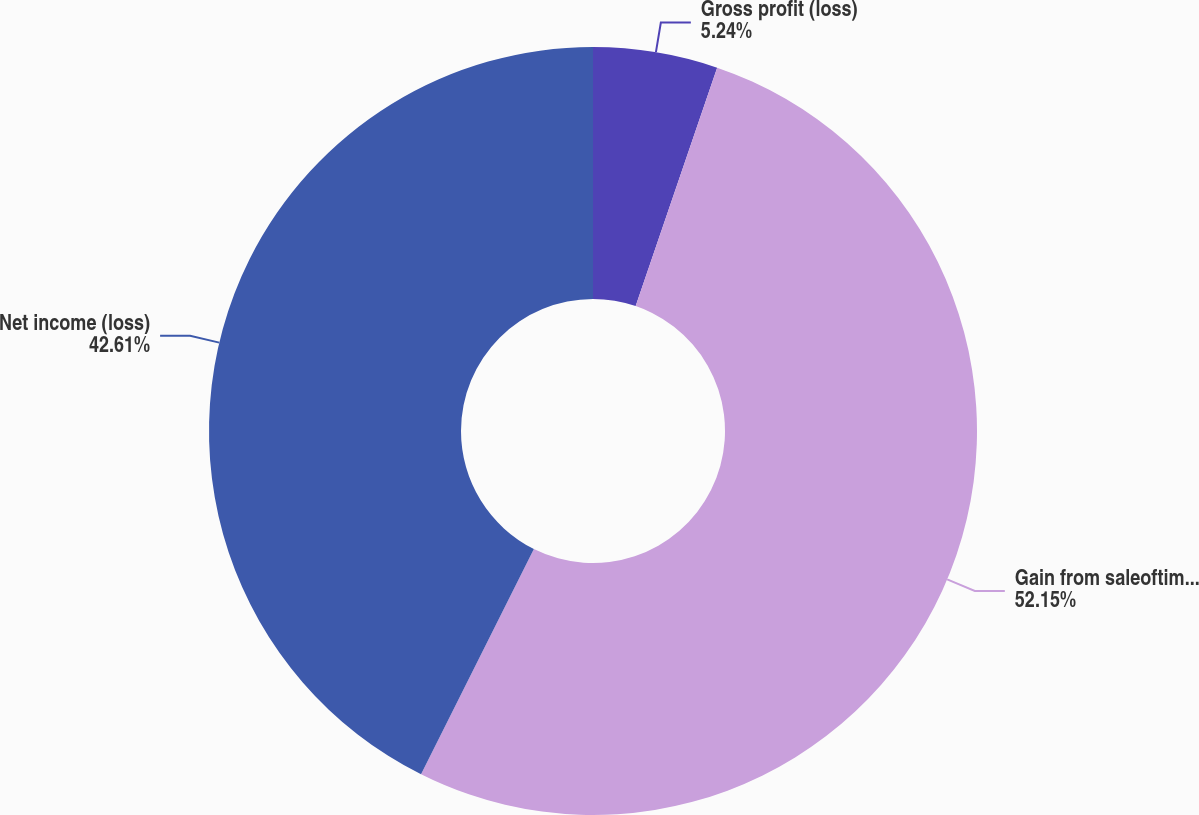<chart> <loc_0><loc_0><loc_500><loc_500><pie_chart><fcel>Gross profit (loss)<fcel>Gain from saleoftimberlands<fcel>Net income (loss)<nl><fcel>5.24%<fcel>52.15%<fcel>42.61%<nl></chart> 